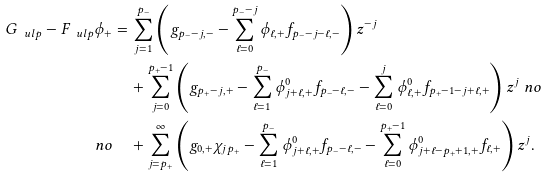Convert formula to latex. <formula><loc_0><loc_0><loc_500><loc_500>G _ { \ u l p } - F _ { \ u l p } \phi _ { + } & = \sum _ { j = 1 } ^ { p _ { - } } \left ( g _ { p _ { - } - j , - } - \sum _ { \ell = 0 } ^ { p _ { - } - j } \phi _ { \ell , + } f _ { p _ { - } - j - \ell , - } \right ) z ^ { - j } \\ & \quad + \sum _ { j = 0 } ^ { p _ { + } - 1 } \left ( g _ { p _ { + } - j , + } - \sum _ { \ell = 1 } ^ { p _ { - } } \phi _ { j + \ell , + } ^ { 0 } f _ { p _ { - } - \ell , - } - \sum _ { \ell = 0 } ^ { j } \phi _ { \ell , + } ^ { 0 } f _ { p _ { + } - 1 - j + \ell , + } \right ) z ^ { j } \ n o \\ \ n o & \quad + \sum _ { j = p _ { + } } ^ { \infty } \left ( g _ { 0 , + } \chi _ { j p _ { + } } - \sum _ { \ell = 1 } ^ { p _ { - } } \phi _ { j + \ell , + } ^ { 0 } f _ { p _ { - } - \ell , - } - \sum _ { \ell = 0 } ^ { p _ { + } - 1 } \phi _ { j + \ell - p _ { + } + 1 , + } ^ { 0 } f _ { \ell , + } \right ) z ^ { j } .</formula> 